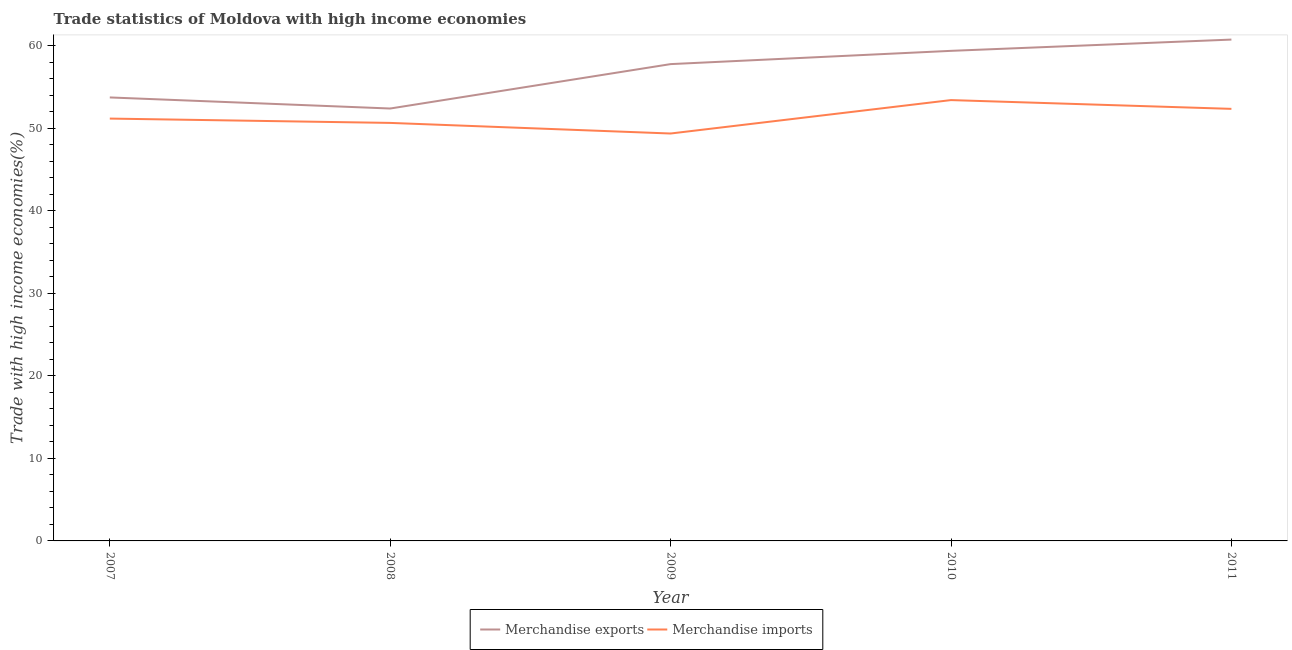How many different coloured lines are there?
Your answer should be very brief. 2. Does the line corresponding to merchandise exports intersect with the line corresponding to merchandise imports?
Your answer should be very brief. No. What is the merchandise exports in 2011?
Provide a short and direct response. 60.72. Across all years, what is the maximum merchandise exports?
Ensure brevity in your answer.  60.72. Across all years, what is the minimum merchandise exports?
Your response must be concise. 52.37. In which year was the merchandise imports maximum?
Your answer should be compact. 2010. In which year was the merchandise exports minimum?
Your response must be concise. 2008. What is the total merchandise exports in the graph?
Your answer should be compact. 283.9. What is the difference between the merchandise exports in 2007 and that in 2008?
Make the answer very short. 1.34. What is the difference between the merchandise imports in 2007 and the merchandise exports in 2008?
Offer a terse response. -1.22. What is the average merchandise exports per year?
Offer a very short reply. 56.78. In the year 2008, what is the difference between the merchandise imports and merchandise exports?
Your answer should be compact. -1.74. What is the ratio of the merchandise imports in 2007 to that in 2008?
Your answer should be compact. 1.01. What is the difference between the highest and the second highest merchandise imports?
Your answer should be very brief. 1.06. What is the difference between the highest and the lowest merchandise imports?
Give a very brief answer. 4.05. In how many years, is the merchandise imports greater than the average merchandise imports taken over all years?
Your response must be concise. 2. Is the sum of the merchandise exports in 2010 and 2011 greater than the maximum merchandise imports across all years?
Provide a succinct answer. Yes. Does the merchandise imports monotonically increase over the years?
Your answer should be compact. No. How many lines are there?
Your response must be concise. 2. How many years are there in the graph?
Give a very brief answer. 5. What is the difference between two consecutive major ticks on the Y-axis?
Give a very brief answer. 10. Does the graph contain grids?
Keep it short and to the point. No. Where does the legend appear in the graph?
Offer a very short reply. Bottom center. How many legend labels are there?
Make the answer very short. 2. How are the legend labels stacked?
Keep it short and to the point. Horizontal. What is the title of the graph?
Provide a short and direct response. Trade statistics of Moldova with high income economies. What is the label or title of the X-axis?
Offer a very short reply. Year. What is the label or title of the Y-axis?
Ensure brevity in your answer.  Trade with high income economies(%). What is the Trade with high income economies(%) in Merchandise exports in 2007?
Offer a very short reply. 53.71. What is the Trade with high income economies(%) of Merchandise imports in 2007?
Provide a succinct answer. 51.15. What is the Trade with high income economies(%) of Merchandise exports in 2008?
Provide a succinct answer. 52.37. What is the Trade with high income economies(%) in Merchandise imports in 2008?
Ensure brevity in your answer.  50.63. What is the Trade with high income economies(%) in Merchandise exports in 2009?
Keep it short and to the point. 57.75. What is the Trade with high income economies(%) of Merchandise imports in 2009?
Offer a very short reply. 49.34. What is the Trade with high income economies(%) of Merchandise exports in 2010?
Ensure brevity in your answer.  59.35. What is the Trade with high income economies(%) of Merchandise imports in 2010?
Your answer should be very brief. 53.39. What is the Trade with high income economies(%) in Merchandise exports in 2011?
Your answer should be very brief. 60.72. What is the Trade with high income economies(%) in Merchandise imports in 2011?
Your answer should be very brief. 52.33. Across all years, what is the maximum Trade with high income economies(%) of Merchandise exports?
Offer a terse response. 60.72. Across all years, what is the maximum Trade with high income economies(%) in Merchandise imports?
Keep it short and to the point. 53.39. Across all years, what is the minimum Trade with high income economies(%) in Merchandise exports?
Make the answer very short. 52.37. Across all years, what is the minimum Trade with high income economies(%) of Merchandise imports?
Offer a terse response. 49.34. What is the total Trade with high income economies(%) of Merchandise exports in the graph?
Ensure brevity in your answer.  283.9. What is the total Trade with high income economies(%) of Merchandise imports in the graph?
Give a very brief answer. 256.83. What is the difference between the Trade with high income economies(%) in Merchandise exports in 2007 and that in 2008?
Offer a terse response. 1.34. What is the difference between the Trade with high income economies(%) in Merchandise imports in 2007 and that in 2008?
Your response must be concise. 0.52. What is the difference between the Trade with high income economies(%) in Merchandise exports in 2007 and that in 2009?
Your answer should be very brief. -4.04. What is the difference between the Trade with high income economies(%) in Merchandise imports in 2007 and that in 2009?
Ensure brevity in your answer.  1.81. What is the difference between the Trade with high income economies(%) in Merchandise exports in 2007 and that in 2010?
Ensure brevity in your answer.  -5.64. What is the difference between the Trade with high income economies(%) in Merchandise imports in 2007 and that in 2010?
Make the answer very short. -2.24. What is the difference between the Trade with high income economies(%) in Merchandise exports in 2007 and that in 2011?
Offer a very short reply. -7.01. What is the difference between the Trade with high income economies(%) in Merchandise imports in 2007 and that in 2011?
Give a very brief answer. -1.18. What is the difference between the Trade with high income economies(%) of Merchandise exports in 2008 and that in 2009?
Your response must be concise. -5.38. What is the difference between the Trade with high income economies(%) of Merchandise imports in 2008 and that in 2009?
Provide a short and direct response. 1.28. What is the difference between the Trade with high income economies(%) of Merchandise exports in 2008 and that in 2010?
Your response must be concise. -6.98. What is the difference between the Trade with high income economies(%) in Merchandise imports in 2008 and that in 2010?
Make the answer very short. -2.76. What is the difference between the Trade with high income economies(%) of Merchandise exports in 2008 and that in 2011?
Keep it short and to the point. -8.35. What is the difference between the Trade with high income economies(%) in Merchandise imports in 2008 and that in 2011?
Your answer should be very brief. -1.7. What is the difference between the Trade with high income economies(%) in Merchandise exports in 2009 and that in 2010?
Your answer should be compact. -1.61. What is the difference between the Trade with high income economies(%) in Merchandise imports in 2009 and that in 2010?
Ensure brevity in your answer.  -4.05. What is the difference between the Trade with high income economies(%) of Merchandise exports in 2009 and that in 2011?
Make the answer very short. -2.97. What is the difference between the Trade with high income economies(%) in Merchandise imports in 2009 and that in 2011?
Offer a terse response. -2.99. What is the difference between the Trade with high income economies(%) of Merchandise exports in 2010 and that in 2011?
Ensure brevity in your answer.  -1.36. What is the difference between the Trade with high income economies(%) in Merchandise imports in 2010 and that in 2011?
Provide a succinct answer. 1.06. What is the difference between the Trade with high income economies(%) in Merchandise exports in 2007 and the Trade with high income economies(%) in Merchandise imports in 2008?
Make the answer very short. 3.08. What is the difference between the Trade with high income economies(%) of Merchandise exports in 2007 and the Trade with high income economies(%) of Merchandise imports in 2009?
Give a very brief answer. 4.37. What is the difference between the Trade with high income economies(%) in Merchandise exports in 2007 and the Trade with high income economies(%) in Merchandise imports in 2010?
Your answer should be compact. 0.32. What is the difference between the Trade with high income economies(%) of Merchandise exports in 2007 and the Trade with high income economies(%) of Merchandise imports in 2011?
Keep it short and to the point. 1.38. What is the difference between the Trade with high income economies(%) of Merchandise exports in 2008 and the Trade with high income economies(%) of Merchandise imports in 2009?
Provide a short and direct response. 3.03. What is the difference between the Trade with high income economies(%) in Merchandise exports in 2008 and the Trade with high income economies(%) in Merchandise imports in 2010?
Your response must be concise. -1.02. What is the difference between the Trade with high income economies(%) in Merchandise exports in 2008 and the Trade with high income economies(%) in Merchandise imports in 2011?
Ensure brevity in your answer.  0.04. What is the difference between the Trade with high income economies(%) of Merchandise exports in 2009 and the Trade with high income economies(%) of Merchandise imports in 2010?
Your answer should be compact. 4.36. What is the difference between the Trade with high income economies(%) of Merchandise exports in 2009 and the Trade with high income economies(%) of Merchandise imports in 2011?
Keep it short and to the point. 5.42. What is the difference between the Trade with high income economies(%) in Merchandise exports in 2010 and the Trade with high income economies(%) in Merchandise imports in 2011?
Your response must be concise. 7.03. What is the average Trade with high income economies(%) of Merchandise exports per year?
Provide a short and direct response. 56.78. What is the average Trade with high income economies(%) in Merchandise imports per year?
Keep it short and to the point. 51.37. In the year 2007, what is the difference between the Trade with high income economies(%) of Merchandise exports and Trade with high income economies(%) of Merchandise imports?
Keep it short and to the point. 2.56. In the year 2008, what is the difference between the Trade with high income economies(%) in Merchandise exports and Trade with high income economies(%) in Merchandise imports?
Your answer should be very brief. 1.74. In the year 2009, what is the difference between the Trade with high income economies(%) in Merchandise exports and Trade with high income economies(%) in Merchandise imports?
Ensure brevity in your answer.  8.41. In the year 2010, what is the difference between the Trade with high income economies(%) in Merchandise exports and Trade with high income economies(%) in Merchandise imports?
Offer a very short reply. 5.96. In the year 2011, what is the difference between the Trade with high income economies(%) of Merchandise exports and Trade with high income economies(%) of Merchandise imports?
Offer a terse response. 8.39. What is the ratio of the Trade with high income economies(%) in Merchandise exports in 2007 to that in 2008?
Provide a succinct answer. 1.03. What is the ratio of the Trade with high income economies(%) of Merchandise imports in 2007 to that in 2008?
Offer a very short reply. 1.01. What is the ratio of the Trade with high income economies(%) in Merchandise exports in 2007 to that in 2009?
Provide a succinct answer. 0.93. What is the ratio of the Trade with high income economies(%) of Merchandise imports in 2007 to that in 2009?
Keep it short and to the point. 1.04. What is the ratio of the Trade with high income economies(%) in Merchandise exports in 2007 to that in 2010?
Your answer should be very brief. 0.9. What is the ratio of the Trade with high income economies(%) in Merchandise imports in 2007 to that in 2010?
Make the answer very short. 0.96. What is the ratio of the Trade with high income economies(%) in Merchandise exports in 2007 to that in 2011?
Keep it short and to the point. 0.88. What is the ratio of the Trade with high income economies(%) of Merchandise imports in 2007 to that in 2011?
Keep it short and to the point. 0.98. What is the ratio of the Trade with high income economies(%) in Merchandise exports in 2008 to that in 2009?
Ensure brevity in your answer.  0.91. What is the ratio of the Trade with high income economies(%) of Merchandise exports in 2008 to that in 2010?
Your answer should be compact. 0.88. What is the ratio of the Trade with high income economies(%) of Merchandise imports in 2008 to that in 2010?
Provide a short and direct response. 0.95. What is the ratio of the Trade with high income economies(%) of Merchandise exports in 2008 to that in 2011?
Ensure brevity in your answer.  0.86. What is the ratio of the Trade with high income economies(%) of Merchandise imports in 2008 to that in 2011?
Keep it short and to the point. 0.97. What is the ratio of the Trade with high income economies(%) in Merchandise exports in 2009 to that in 2010?
Offer a terse response. 0.97. What is the ratio of the Trade with high income economies(%) of Merchandise imports in 2009 to that in 2010?
Provide a short and direct response. 0.92. What is the ratio of the Trade with high income economies(%) of Merchandise exports in 2009 to that in 2011?
Make the answer very short. 0.95. What is the ratio of the Trade with high income economies(%) of Merchandise imports in 2009 to that in 2011?
Provide a succinct answer. 0.94. What is the ratio of the Trade with high income economies(%) of Merchandise exports in 2010 to that in 2011?
Make the answer very short. 0.98. What is the ratio of the Trade with high income economies(%) in Merchandise imports in 2010 to that in 2011?
Offer a very short reply. 1.02. What is the difference between the highest and the second highest Trade with high income economies(%) of Merchandise exports?
Your answer should be very brief. 1.36. What is the difference between the highest and the second highest Trade with high income economies(%) of Merchandise imports?
Your answer should be compact. 1.06. What is the difference between the highest and the lowest Trade with high income economies(%) of Merchandise exports?
Your answer should be compact. 8.35. What is the difference between the highest and the lowest Trade with high income economies(%) in Merchandise imports?
Your answer should be compact. 4.05. 